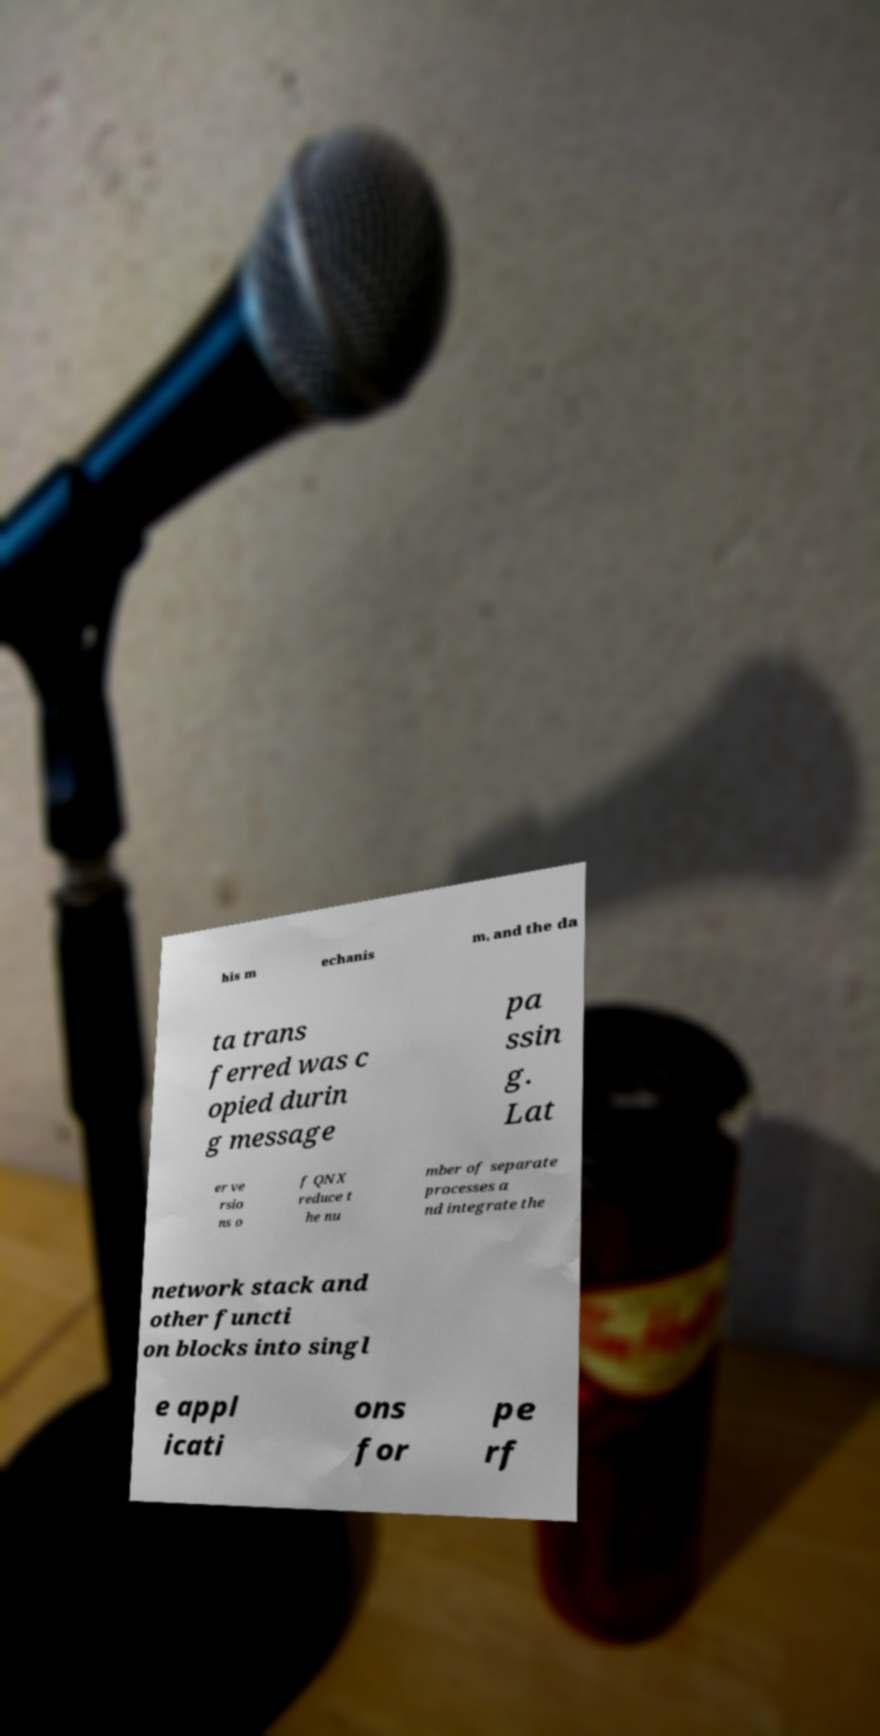Please read and relay the text visible in this image. What does it say? his m echanis m, and the da ta trans ferred was c opied durin g message pa ssin g. Lat er ve rsio ns o f QNX reduce t he nu mber of separate processes a nd integrate the network stack and other functi on blocks into singl e appl icati ons for pe rf 